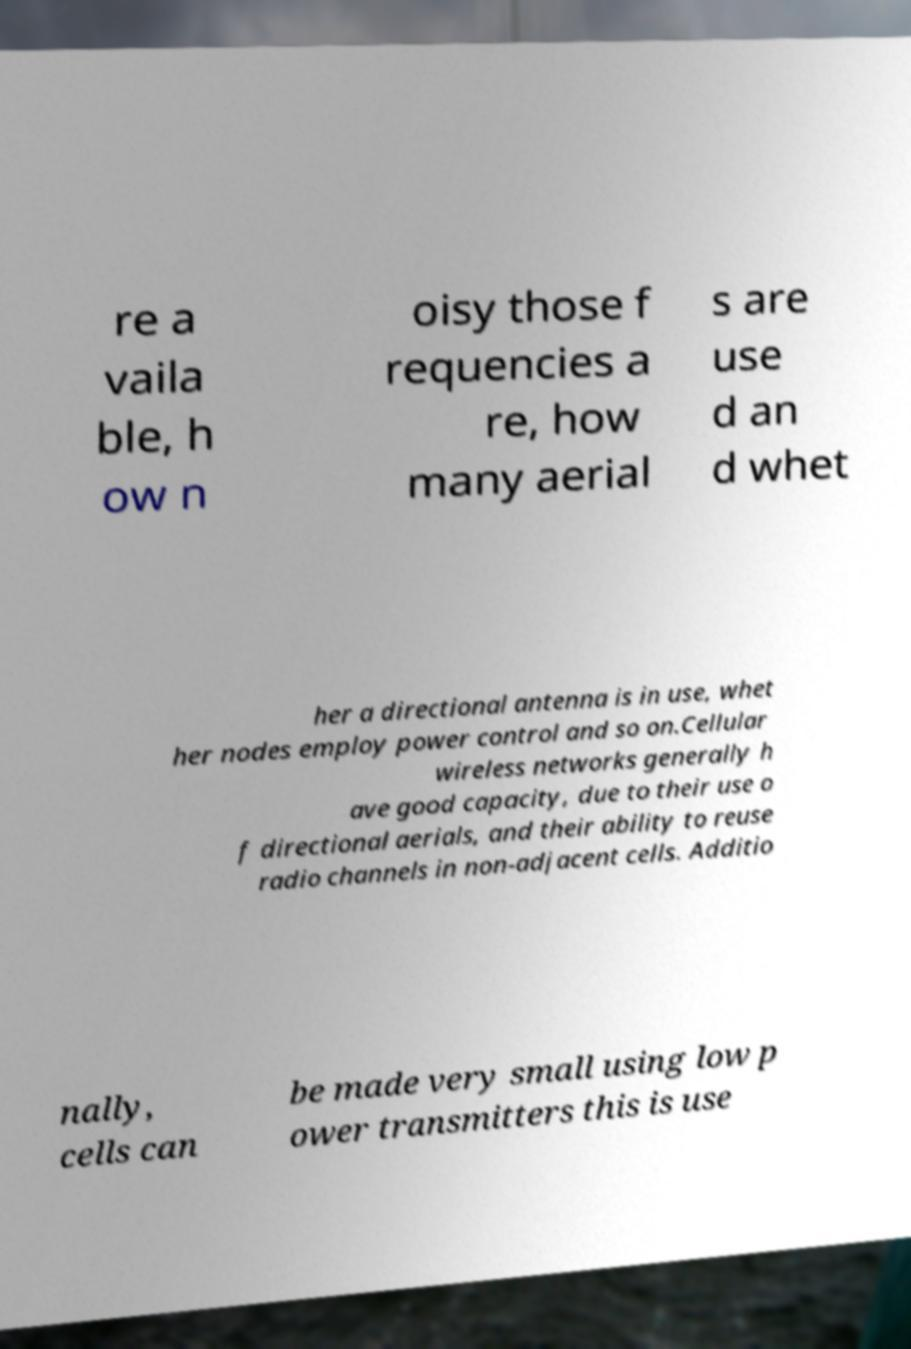Could you assist in decoding the text presented in this image and type it out clearly? re a vaila ble, h ow n oisy those f requencies a re, how many aerial s are use d an d whet her a directional antenna is in use, whet her nodes employ power control and so on.Cellular wireless networks generally h ave good capacity, due to their use o f directional aerials, and their ability to reuse radio channels in non-adjacent cells. Additio nally, cells can be made very small using low p ower transmitters this is use 